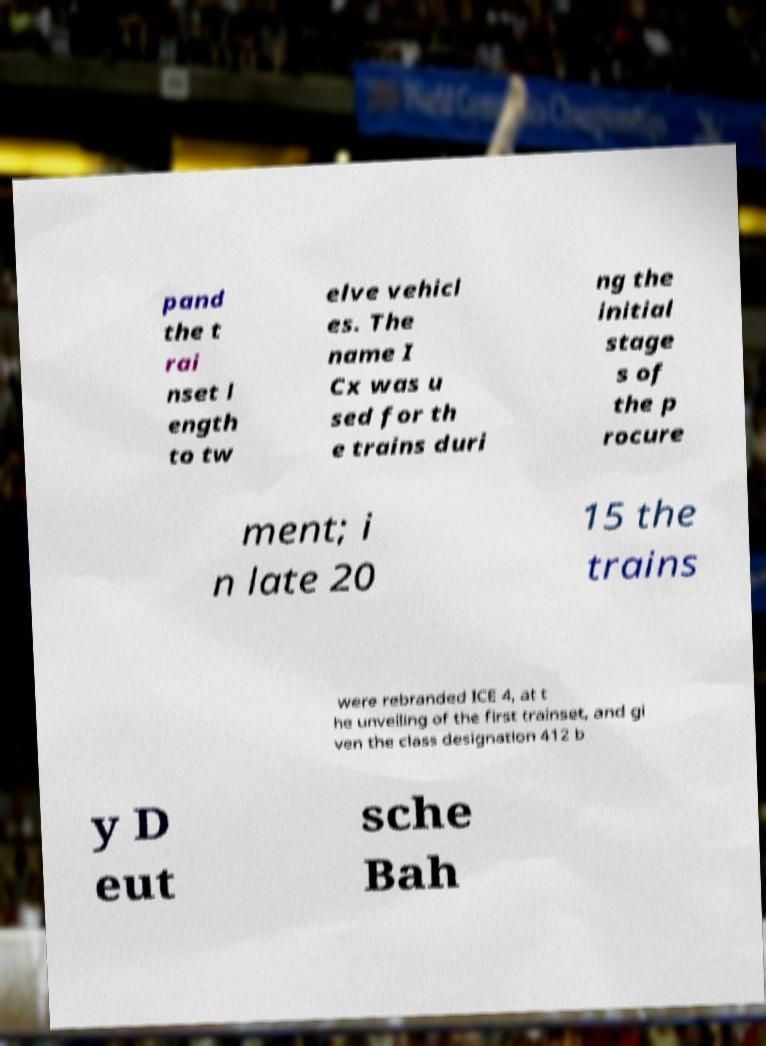For documentation purposes, I need the text within this image transcribed. Could you provide that? pand the t rai nset l ength to tw elve vehicl es. The name I Cx was u sed for th e trains duri ng the initial stage s of the p rocure ment; i n late 20 15 the trains were rebranded ICE 4, at t he unveiling of the first trainset, and gi ven the class designation 412 b y D eut sche Bah 